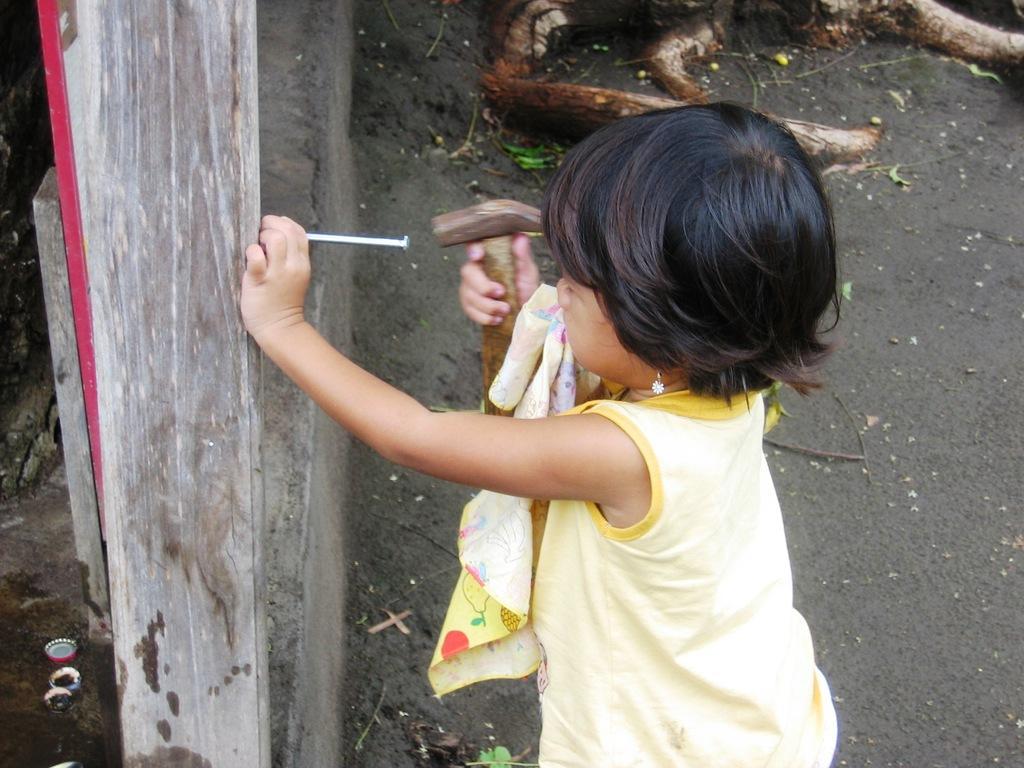Could you give a brief overview of what you see in this image? In this image there is a girl standing on a ground. She is holding a hammer in her hand. In the other hand she is holding a nail. In front of her there is a wall. 